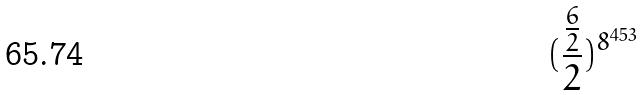<formula> <loc_0><loc_0><loc_500><loc_500>( \frac { \frac { 6 } { 2 } } { 2 } ) ^ { 8 ^ { 4 5 3 } }</formula> 